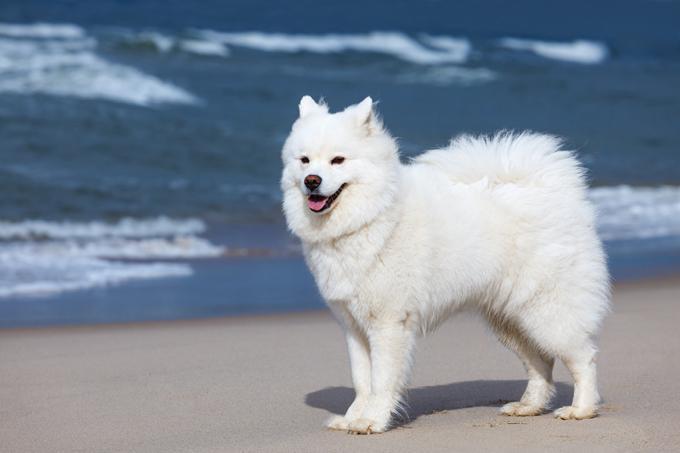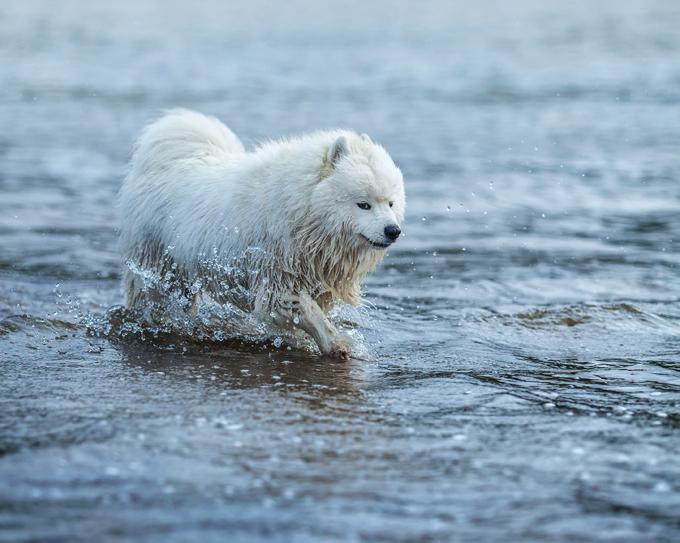The first image is the image on the left, the second image is the image on the right. For the images shown, is this caption "One of the images shows a dog in snow." true? Answer yes or no. No. The first image is the image on the left, the second image is the image on the right. For the images displayed, is the sentence "there is a dog wearing a back pack" factually correct? Answer yes or no. No. The first image is the image on the left, the second image is the image on the right. For the images shown, is this caption "A man is accompanied by a dog, and in one of the photos they are walking across a large log." true? Answer yes or no. No. 